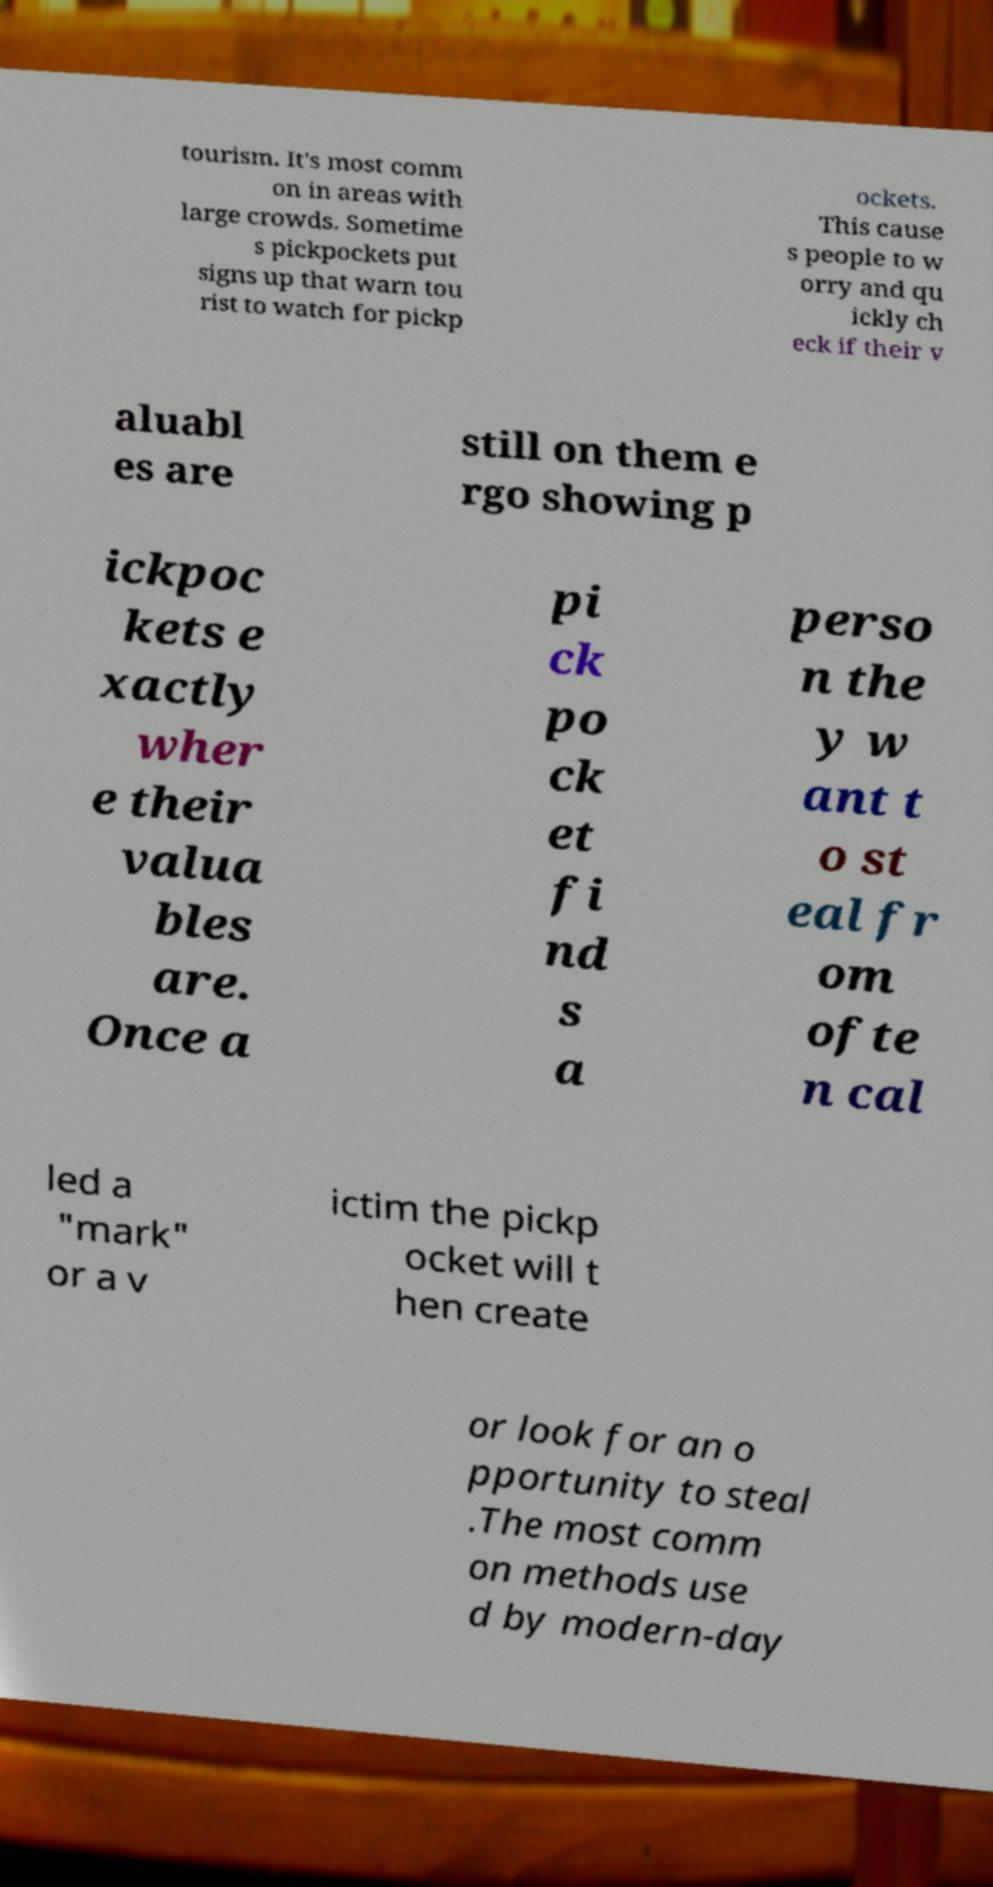I need the written content from this picture converted into text. Can you do that? tourism. It's most comm on in areas with large crowds. Sometime s pickpockets put signs up that warn tou rist to watch for pickp ockets. This cause s people to w orry and qu ickly ch eck if their v aluabl es are still on them e rgo showing p ickpoc kets e xactly wher e their valua bles are. Once a pi ck po ck et fi nd s a perso n the y w ant t o st eal fr om ofte n cal led a "mark" or a v ictim the pickp ocket will t hen create or look for an o pportunity to steal .The most comm on methods use d by modern-day 